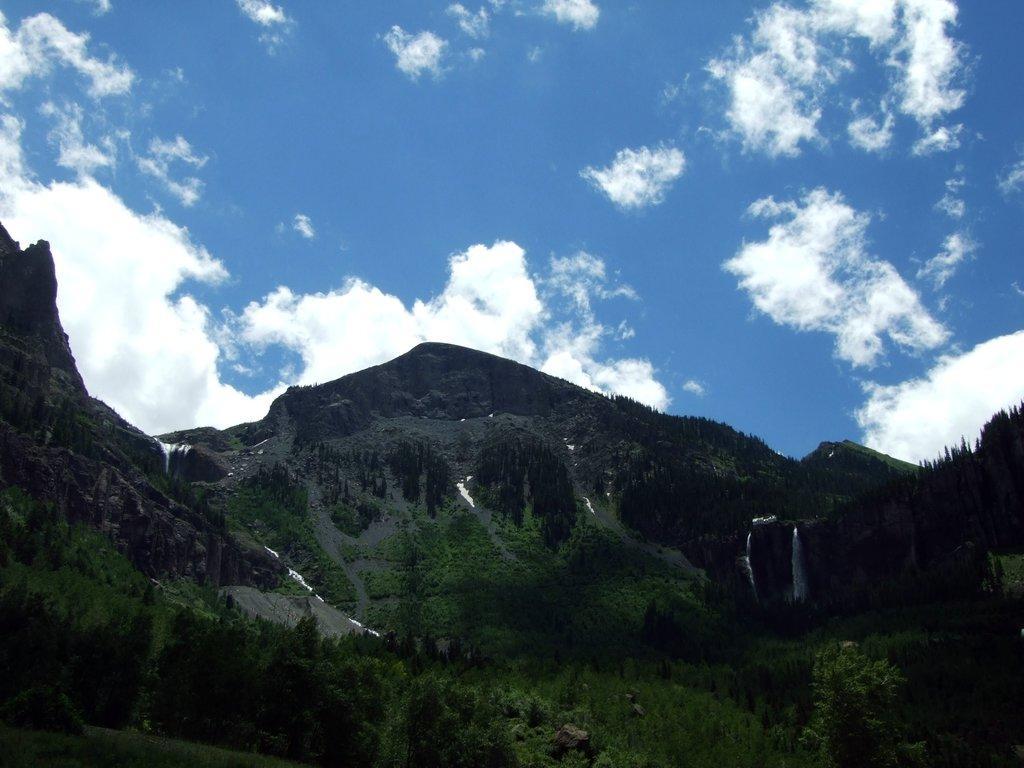In one or two sentences, can you explain what this image depicts? In this image there are mountains trees,in the background there is a blue sky. 